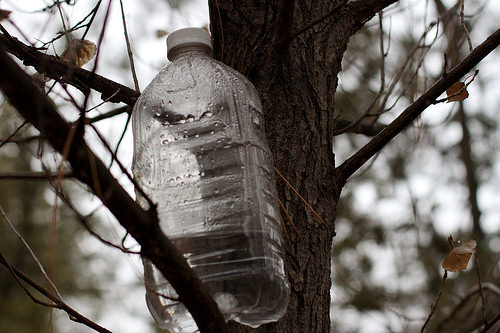<image>
Is there a tree in the bottle? No. The tree is not contained within the bottle. These objects have a different spatial relationship. 